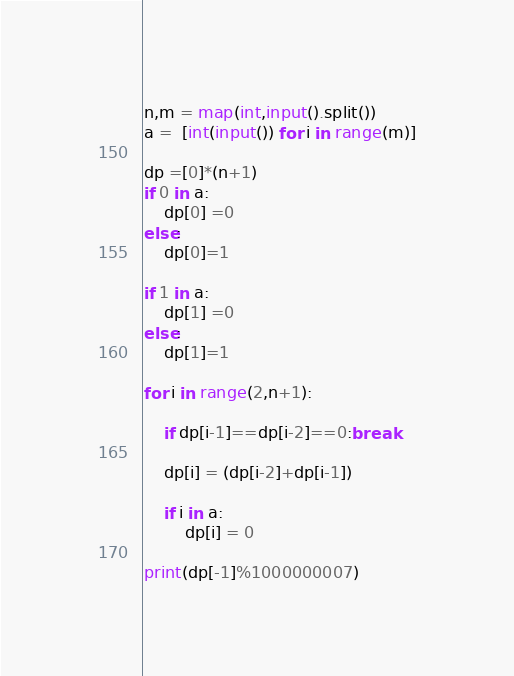Convert code to text. <code><loc_0><loc_0><loc_500><loc_500><_Python_>n,m = map(int,input().split())
a =  [int(input()) for i in range(m)]

dp =[0]*(n+1)
if 0 in a:
    dp[0] =0
else:
    dp[0]=1

if 1 in a:
    dp[1] =0
else:
    dp[1]=1

for i in range(2,n+1):

    if dp[i-1]==dp[i-2]==0:break

    dp[i] = (dp[i-2]+dp[i-1])

    if i in a:
        dp[i] = 0

print(dp[-1]%1000000007)</code> 